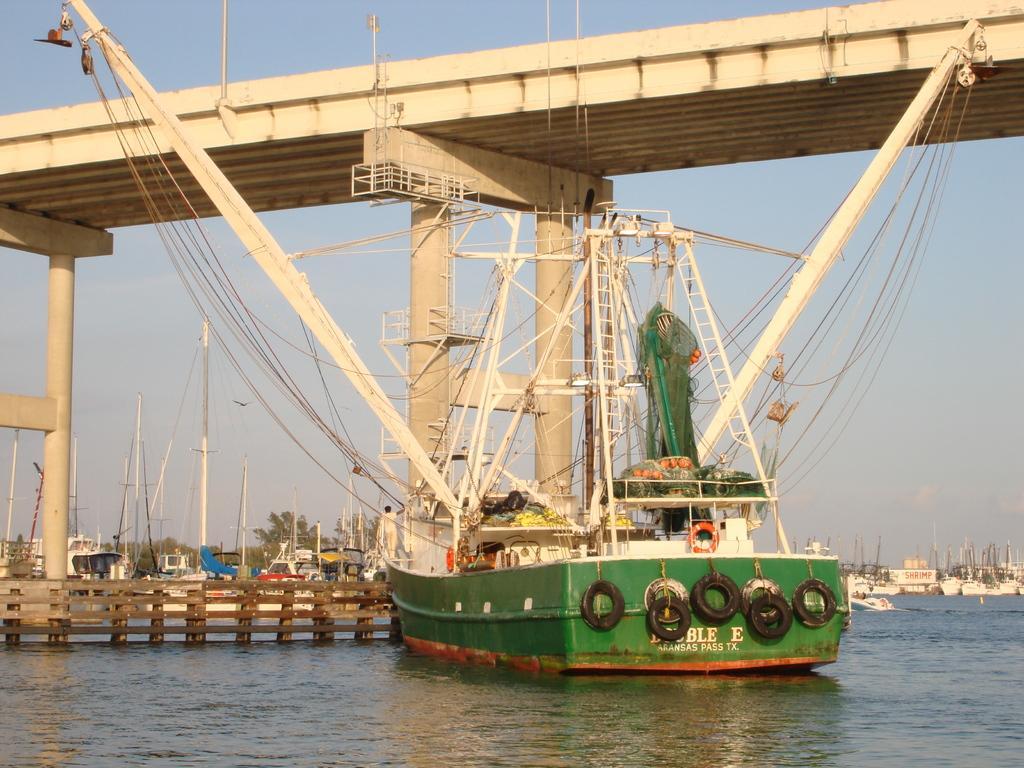Could you give a brief overview of what you see in this image? In this picture I can observe a boat floating on the water in the middle of the picture. On the left side I can observe wooden railing. In the top of the picture I can observe a bridge. In the background I can observe sky. 